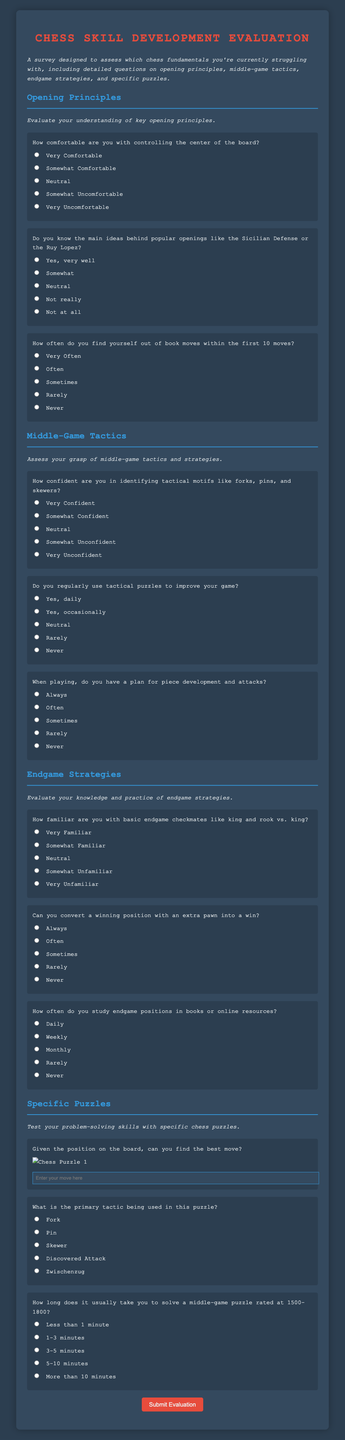What is the title of the survey? The title of the survey is clearly stated at the top of the document.
Answer: Chess Skill Development Evaluation How many sections are in the survey? There are four distinct sections identified by their headings in the document.
Answer: Four What color is the background of the form? The background color is specified in the CSS styles section of the document.
Answer: Dark gray What type of question is asked regarding controlling the center? The nature of the question is about self-assessment of comfort levels, falling under the category of comfort-based inquiries.
Answer: Self-assessment How does the survey ask about the frequency of solving tactical puzzles? The survey uses a frequency-based question format to gauge the respondent's habits in puzzle solving.
Answer: Frequency-based question 